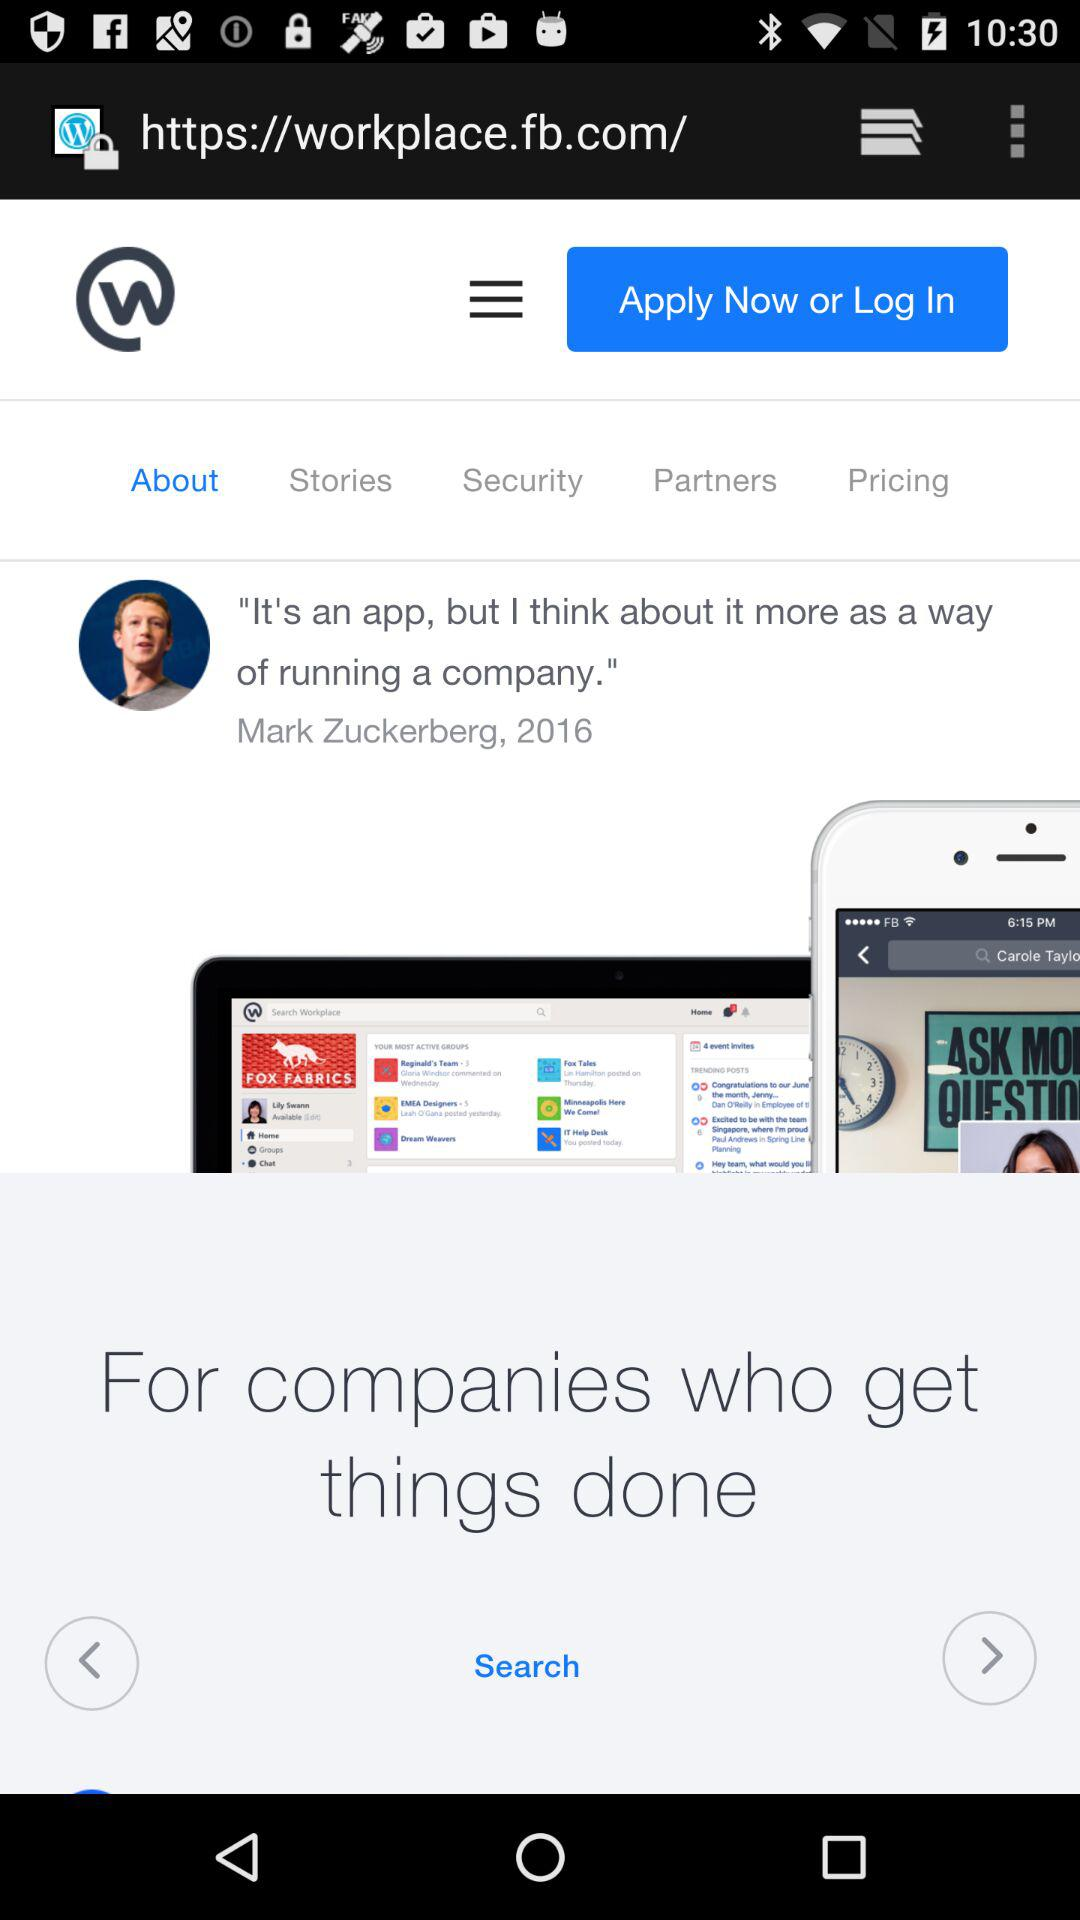Which tab is selected? The selected tab is "About". 